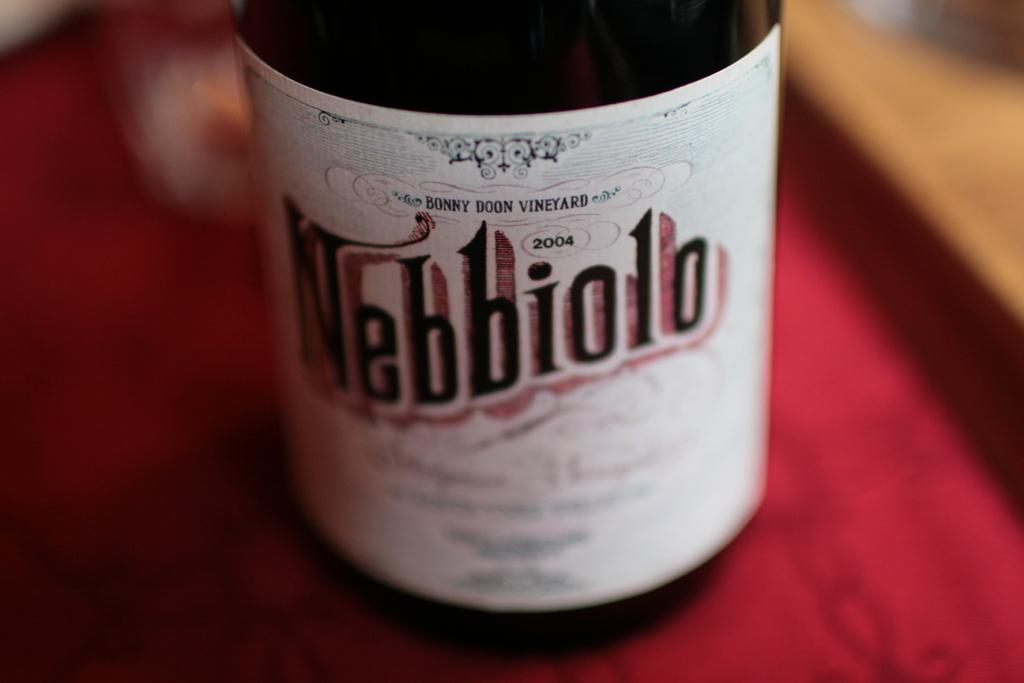<image>
Present a compact description of the photo's key features. A bottle of nebbiolo sits on a red table cloth 